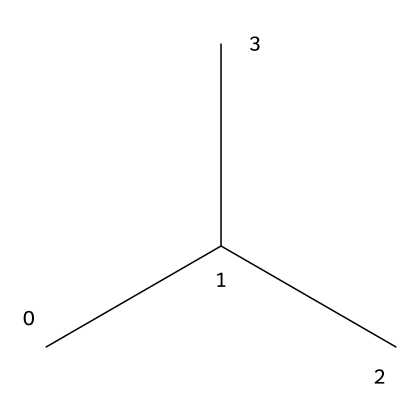What is the molecular formula for R-600a? The molecular formula can be derived by counting the number of carbon (C) and hydrogen (H) atoms present in the SMILES representation. In CC(C)C, there are four carbon atoms and ten hydrogen atoms, resulting in the formula C4H10.
Answer: C4H10 How many carbon atoms are in isobutane? The SMILES representation CC(C)C reveals the carbon backbone of the molecule. By counting the "C" letters, we find a total of four carbon atoms.
Answer: 4 How many hydrogen atoms are attached to each carbon in R-600a? In a branched alkane like isobutane, each carbon atom forms enough bonds to have four total connections. The branching leads to a variation in hydrogen attachment, but in this case, it exhibits a total of ten hydrogens shared across the four carbons.
Answer: 10 What type of compound is R-600a? R-600a is categorized as a hydrocarbon based on its structure, which consists solely of carbon and hydrogen atoms without other functional groups. Specifically, it is an alkane due to having single C-C bonds only.
Answer: hydrocarbon What is the role of R-600a in refrigerants? R-600a serves as a refrigerant due to its favorable thermodynamic properties, which allow it to easily change from liquid to gas and absorb heat efficiently, making it effective for cooling applications.
Answer: refrigerant Is R-600a considered a green refrigerant? R-600a is classified as a green refrigerant as it has low global warming potential and does not deplete the ozone layer, making it environmentally friendly compared to many traditional refrigerants.
Answer: yes 